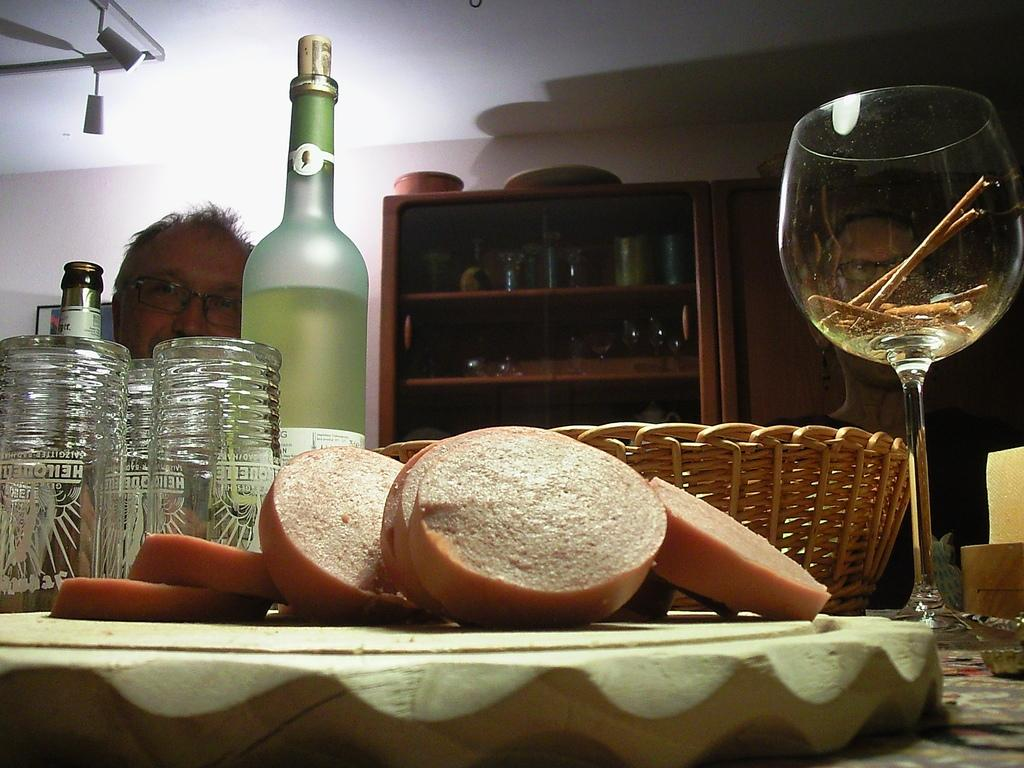What objects can be seen in the image related to serving or consuming beverages? There are bottles and glasses in the image. What other items are present in the image that might be used for eating or drinking? There is a set of utensils in the image. Where is the set of utensils located in the image? The set of utensils is at the right side of the image. Who is present in the image? There is a man sitting in the image. Where is the man sitting in the image? The man is sitting at the left side of the image. What type of skirt is the man wearing in the image? The man is not wearing a skirt in the image; he is sitting with his legs crossed. Is there a drain visible in the image? There is no drain present in the image. 